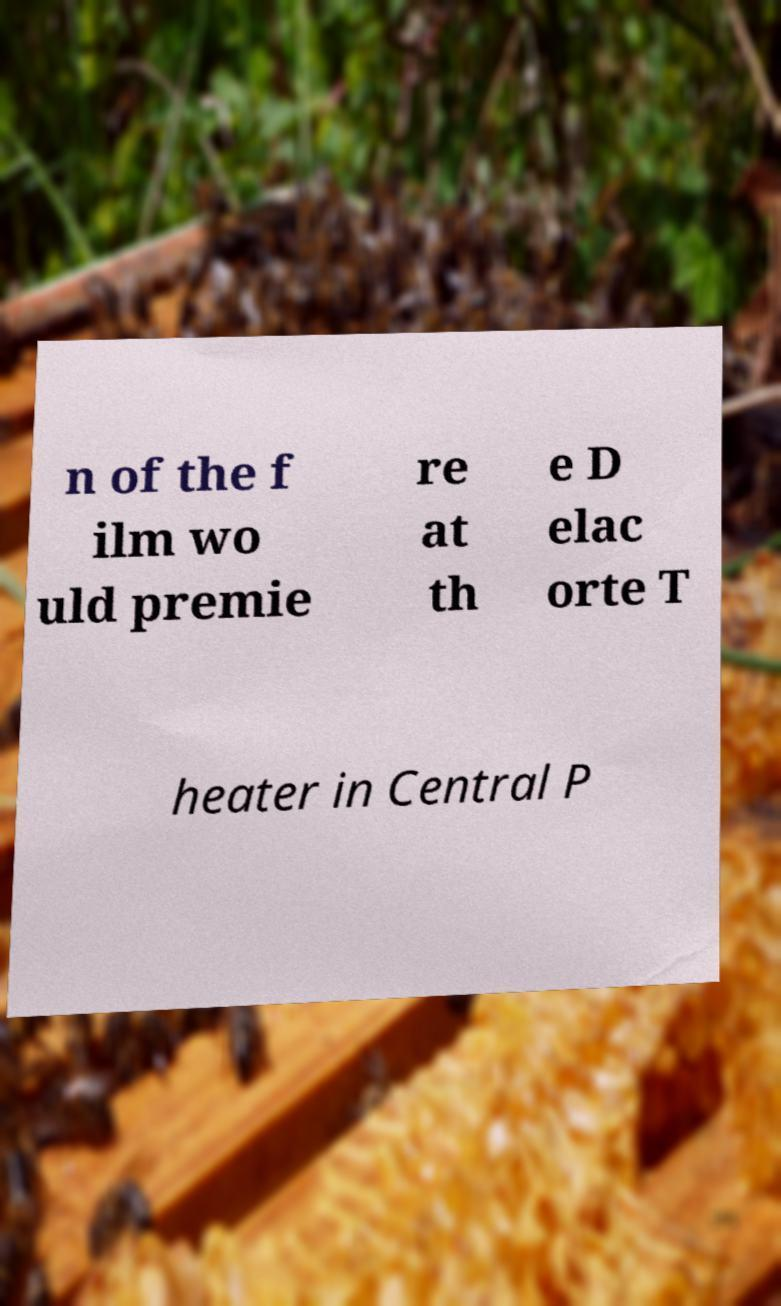Could you assist in decoding the text presented in this image and type it out clearly? n of the f ilm wo uld premie re at th e D elac orte T heater in Central P 